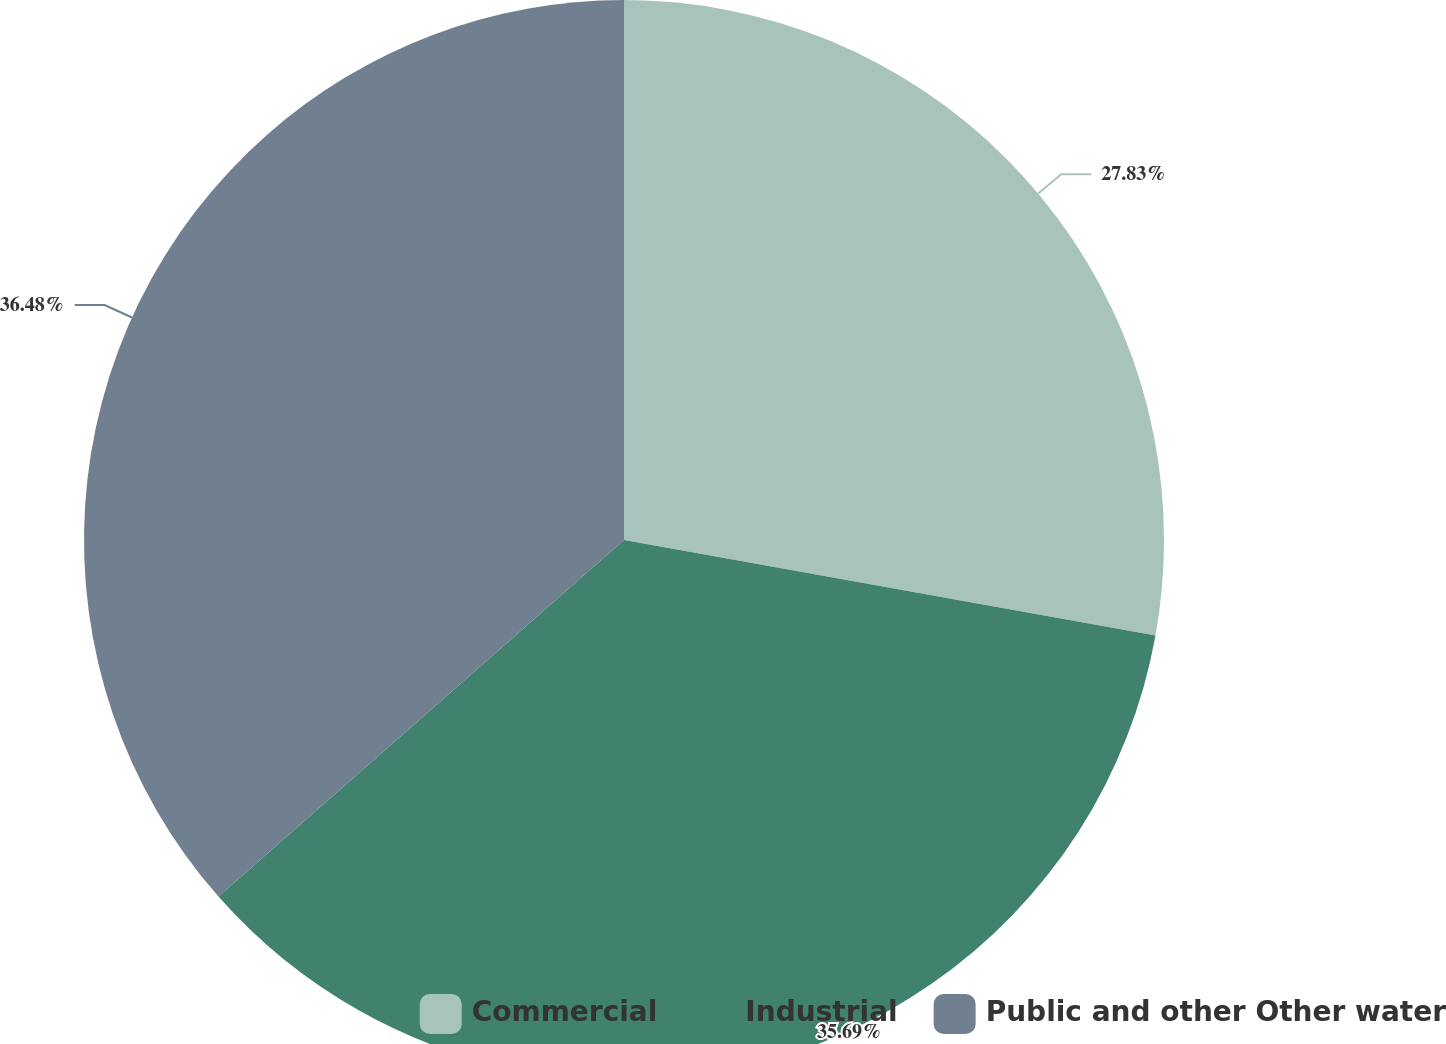Convert chart to OTSL. <chart><loc_0><loc_0><loc_500><loc_500><pie_chart><fcel>Commercial<fcel>Industrial<fcel>Public and other Other water<nl><fcel>27.83%<fcel>35.69%<fcel>36.48%<nl></chart> 